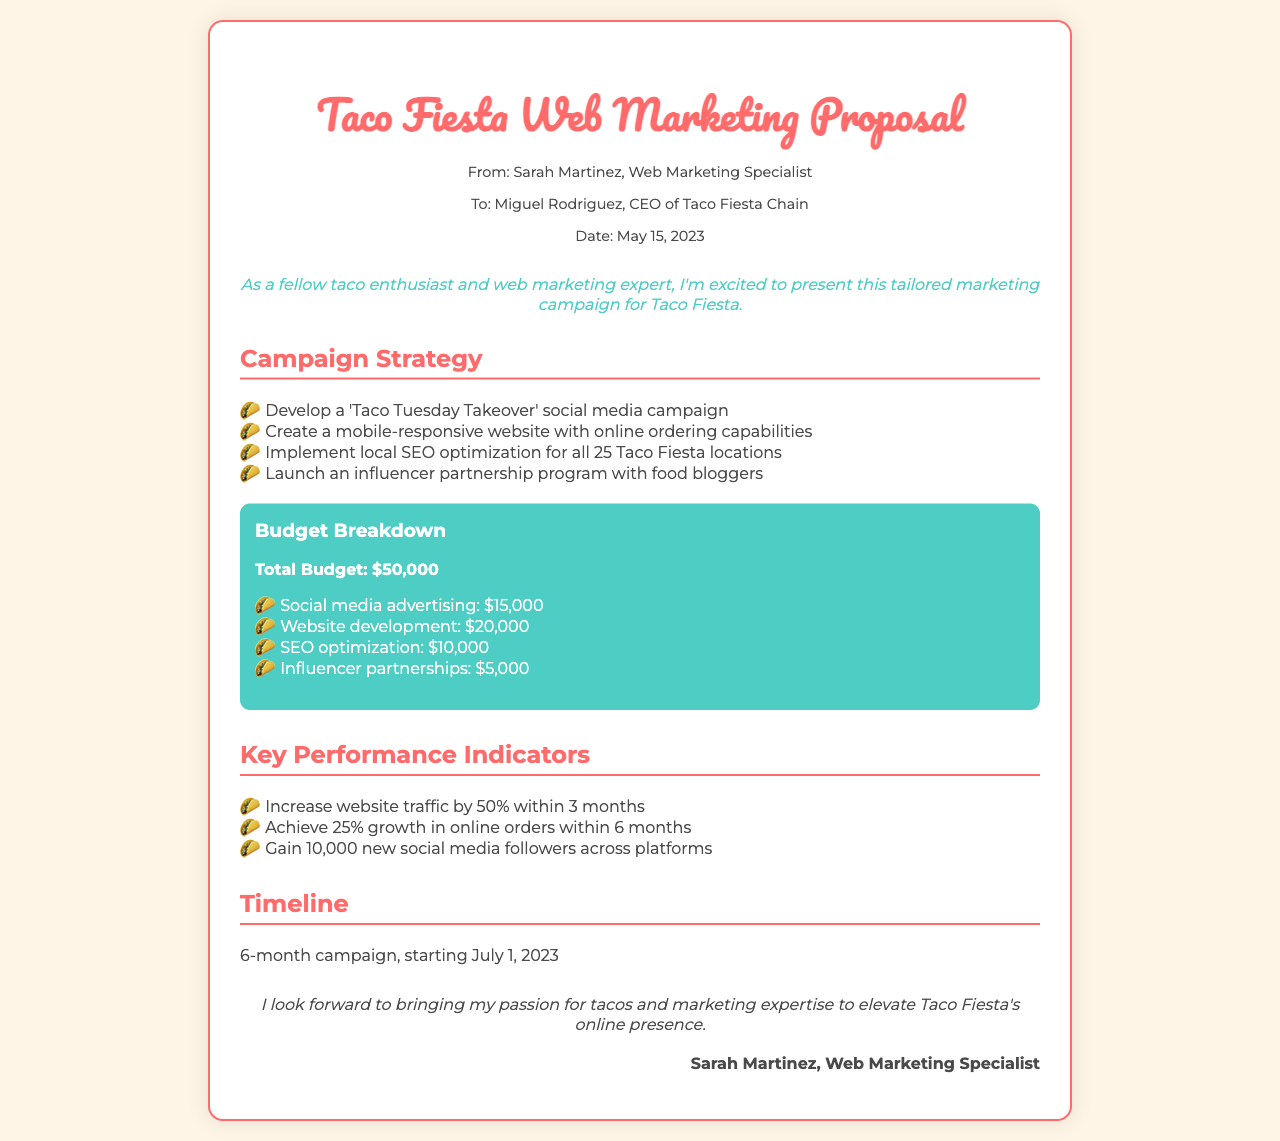what is the total budget for the campaign? The total budget is clearly mentioned in the budget section of the document, which presents the entire amount allocated for the marketing campaign.
Answer: $50,000 who is the recipient of the proposal? The fax indicates that the proposal is directed to Miguel Rodriguez, the CEO of Taco Fiesta Chain.
Answer: Miguel Rodriguez what is one of the key performance indicators mentioned? The document lists specific performance indicators under the Key Performance Indicators section, highlighting critical growth objectives for the campaign.
Answer: Increase website traffic by 50% within 3 months what is the starting date of the campaign? The document provides a clear timeline stating the commencement date of the marketing campaign within the Timeline section.
Answer: July 1, 2023 how much is allocated for social media advertising? The budget breakdown details the specific amounts allocated for various marketing activities, including social media advertising.
Answer: $15,000 what is the name of the marketing campaign proposed? The title at the top of the document reveals the name of the campaign proposed for the Taco restaurant chain.
Answer: Taco Fiesta Web Marketing Proposal how long is the duration of the campaign? The document outlines the overall timeline for the campaign, specifying how long it is expected to run.
Answer: 6 months what is one strategy planned for the campaign? The Campaign Strategy section lists several detailed strategies that will be employed to promote Taco Fiesta effectively.
Answer: Develop a 'Taco Tuesday Takeover' social media campaign 